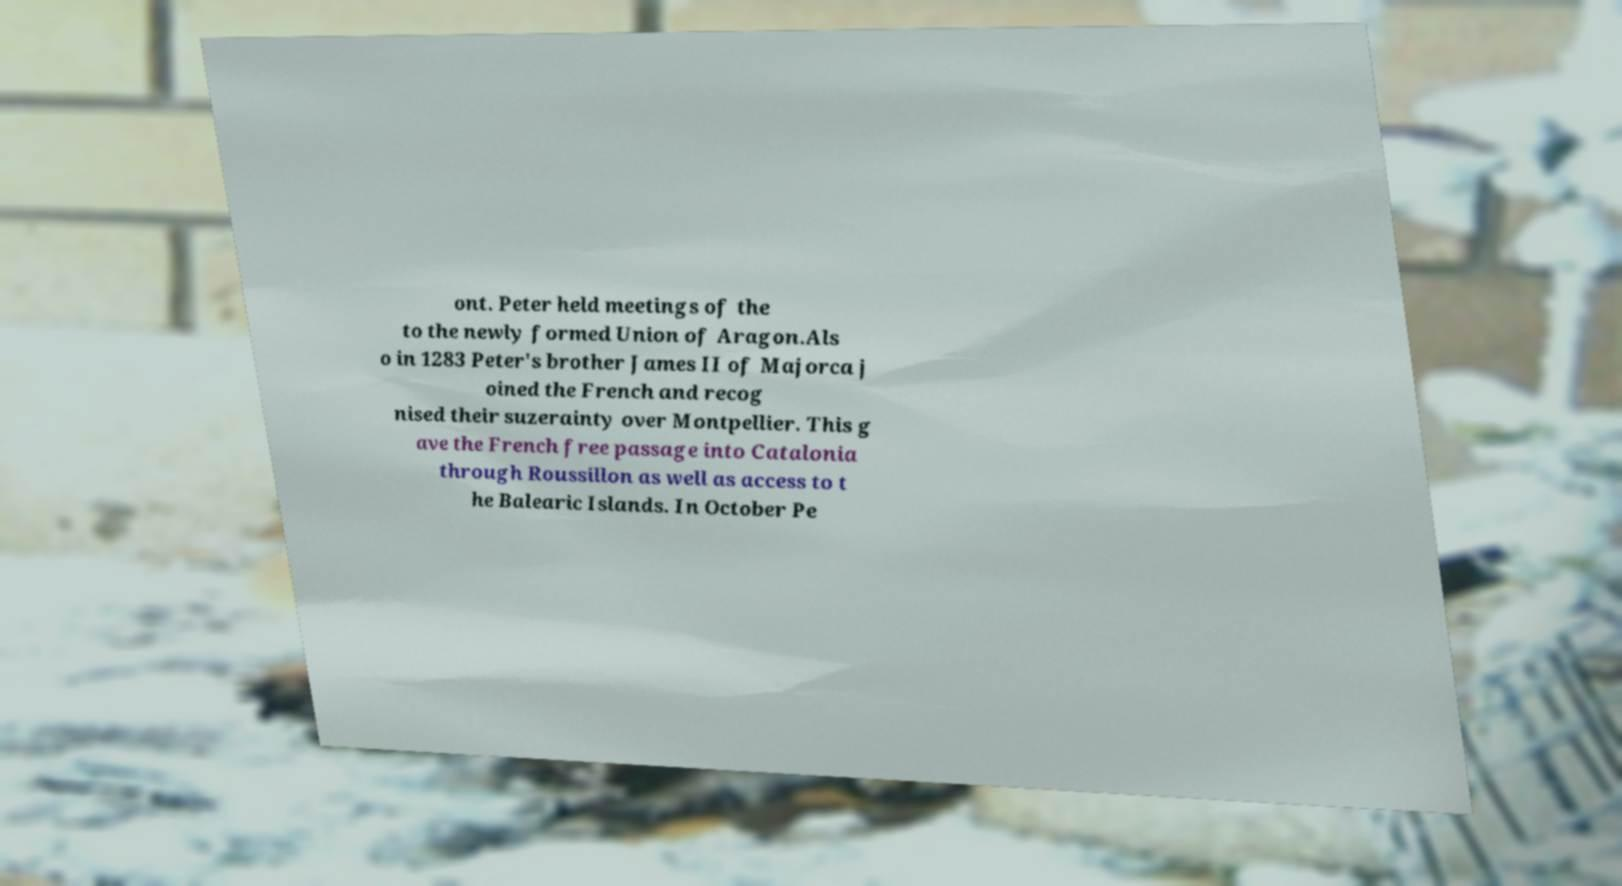Please identify and transcribe the text found in this image. ont. Peter held meetings of the to the newly formed Union of Aragon.Als o in 1283 Peter's brother James II of Majorca j oined the French and recog nised their suzerainty over Montpellier. This g ave the French free passage into Catalonia through Roussillon as well as access to t he Balearic Islands. In October Pe 